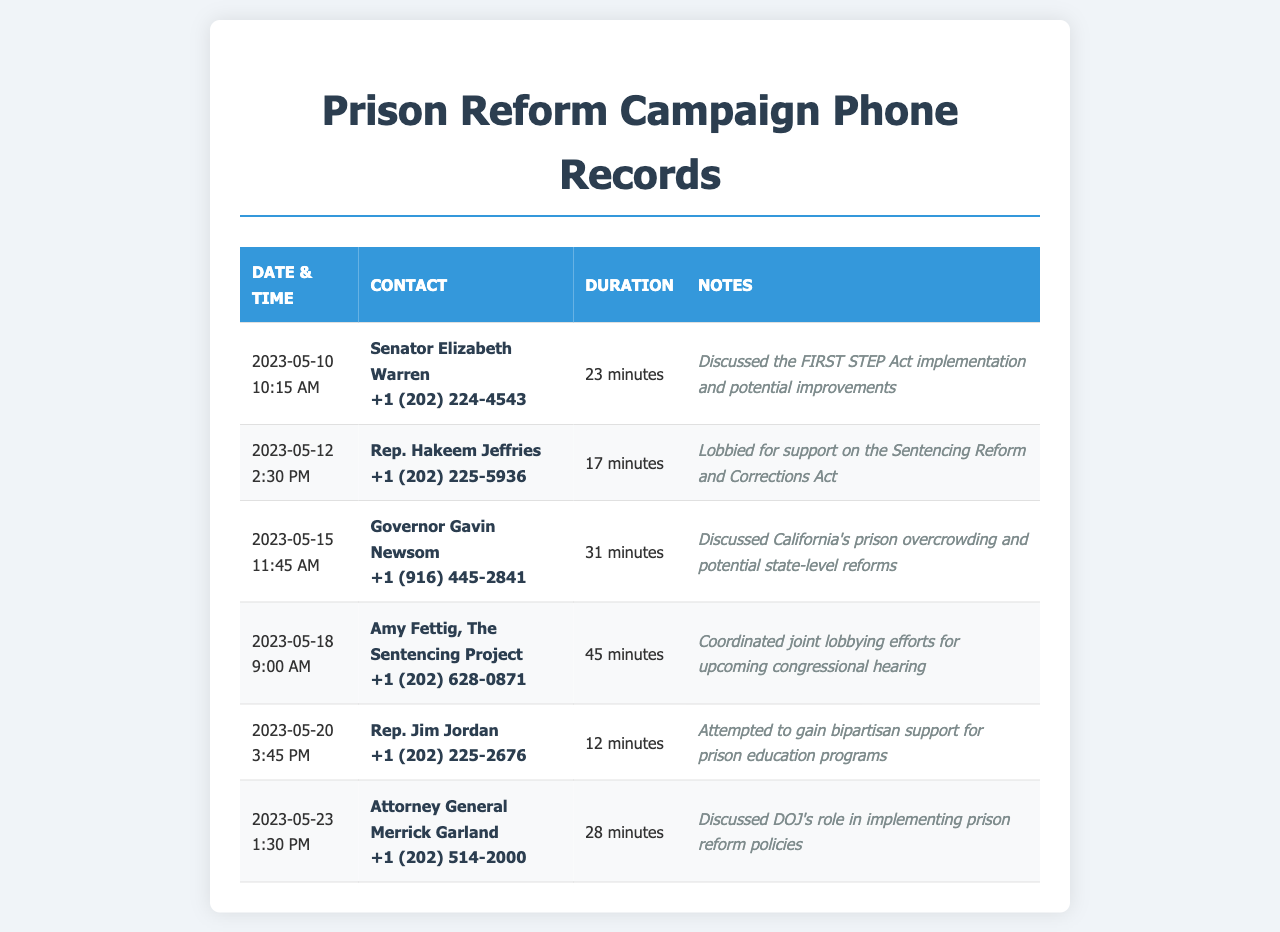What is the date of the call with Senator Elizabeth Warren? The call occurred on May 10, 2023.
Answer: May 10, 2023 How long was the conversation with Amy Fettig? The conversation lasted 45 minutes.
Answer: 45 minutes Who did Rep. Hakeem Jeffries speak with? Rep. Hakeem Jeffries spoke with the contact identified in his entry.
Answer: Rep. Hakeem Jeffries What was discussed during the call with Governor Gavin Newsom? The discussion focused on California's prison overcrowding and potential state-level reforms.
Answer: California's prison overcrowding and potential state-level reforms How many calls were made to legislators in May 2023? There are six entries indicating calls made to legislators during May 2023.
Answer: Six What is the relationship of Attorney General Merrick Garland to the discussion? He was involved in discussing the DOJ's role in implementing prison reform policies.
Answer: DOJ's role in implementing prison reform policies Who is the contact for the call made on May 20? The contact is Rep. Jim Jordan.
Answer: Rep. Jim Jordan Which organization is Amy Fettig associated with? She is associated with The Sentencing Project.
Answer: The Sentencing Project What time was the call with Rep. Jim Jordan? The call was made at 3:45 PM.
Answer: 3:45 PM 